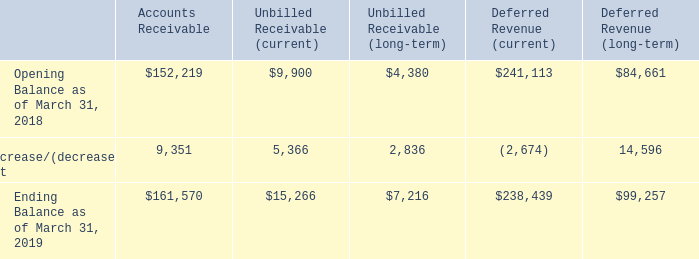Information about Contract Balances
Amounts collected in advance of services being provided are accounted for as deferred revenue. Nearly all of the Company's deferred revenue balance is related to services revenue, primarily customer support contracts.
In some arrangements the Company allows customers to pay for term based software licenses and products over the term of the software license. Amounts recognized as revenue in excess of amounts billed are recorded as unbilled receivables. Unbilled receivables which are anticipated to be invoiced in the next twelve months are included in Accounts receivable on the consolidated balance sheet. Long term unbilled receivables are included in Other assets. The opening and closing balances of the Company’s accounts receivable, unbilled receivables, and deferred revenues are as follows:
The increase in accounts receivable is primarily a result of an increase in subscription software transactions that are recognized as revenue at the time of sale but paid for over time. The net increase in deferred revenue is primarily the result of an increase in deferred customer support revenue related to software and products revenue transactions and customer support renewals during fiscal 2019.
The amount of revenue recognized in the period that was included in the opening deferred revenue balance was $238,603 for the year ended March 31, 2019. The vast majority of this revenue consists of customer support arrangements. The amount of revenue recognized from performance obligations satisfied in prior periods was not material.
Notes to Consolidated Financial Statements — (Continued) (In thousands, except per share data)
What were the reasons given for the change in accounts receivable and deferred revenue between March 2018 and March 2019 respectively? Increase in subscription software transactions that are recognized as revenue at the time of sale but paid for over time, increase in deferred customer support revenue related to software and products revenue transactions and customer support renewals during fiscal 2019. How much is the opening balance for Deferred Revenue (current) and Deferred Revenue (long-term) respectively?
Answer scale should be: thousand. 241,113, 84,661. What is the ending balance as of March 31, 2019 for Accounts Receivables?
Answer scale should be: thousand. $161,570. What is the overall increase，net in opening and closing balances from March 2018 to March 2019?
Answer scale should be: thousand. 9,351+5,366+2,836-2,674+14,596
Answer: 29475. From March 2018 to March 2019, amongst the company's accounts receivable, unbilled receivables (current and long-term), and deferred revenues (current and long-term), how many categories saw a net increase? Accounts Receivable ## Unbilled Receivable (current) ## Unbilled Receivable (long-term) ##Deferred Revenue (long-term)
Answer: 4. How many times more in current unbilled receivables than long-term unbilled receivables did the company have in its opening balance? 9,900/4,380
Answer: 2.26. 